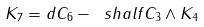Convert formula to latex. <formula><loc_0><loc_0><loc_500><loc_500>K _ { 7 } = d C _ { 6 } - \ s h a l f C _ { 3 } \wedge K _ { 4 }</formula> 